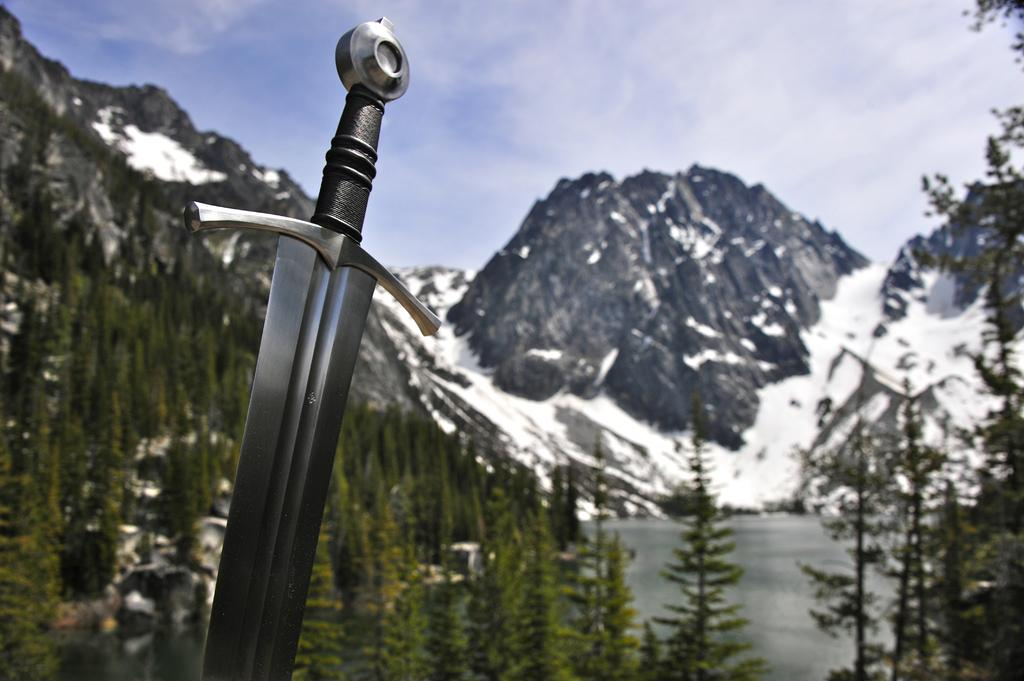What object is located on the left side of the image? There is a sword on the left side of the image. What can be seen in the background of the image? There are trees, mountains, and clouds in the sky in the background of the image. What type of butter is being served at the party in the image? There is no party or butter present in the image; it features a sword and a background with trees, mountains, and clouds. 